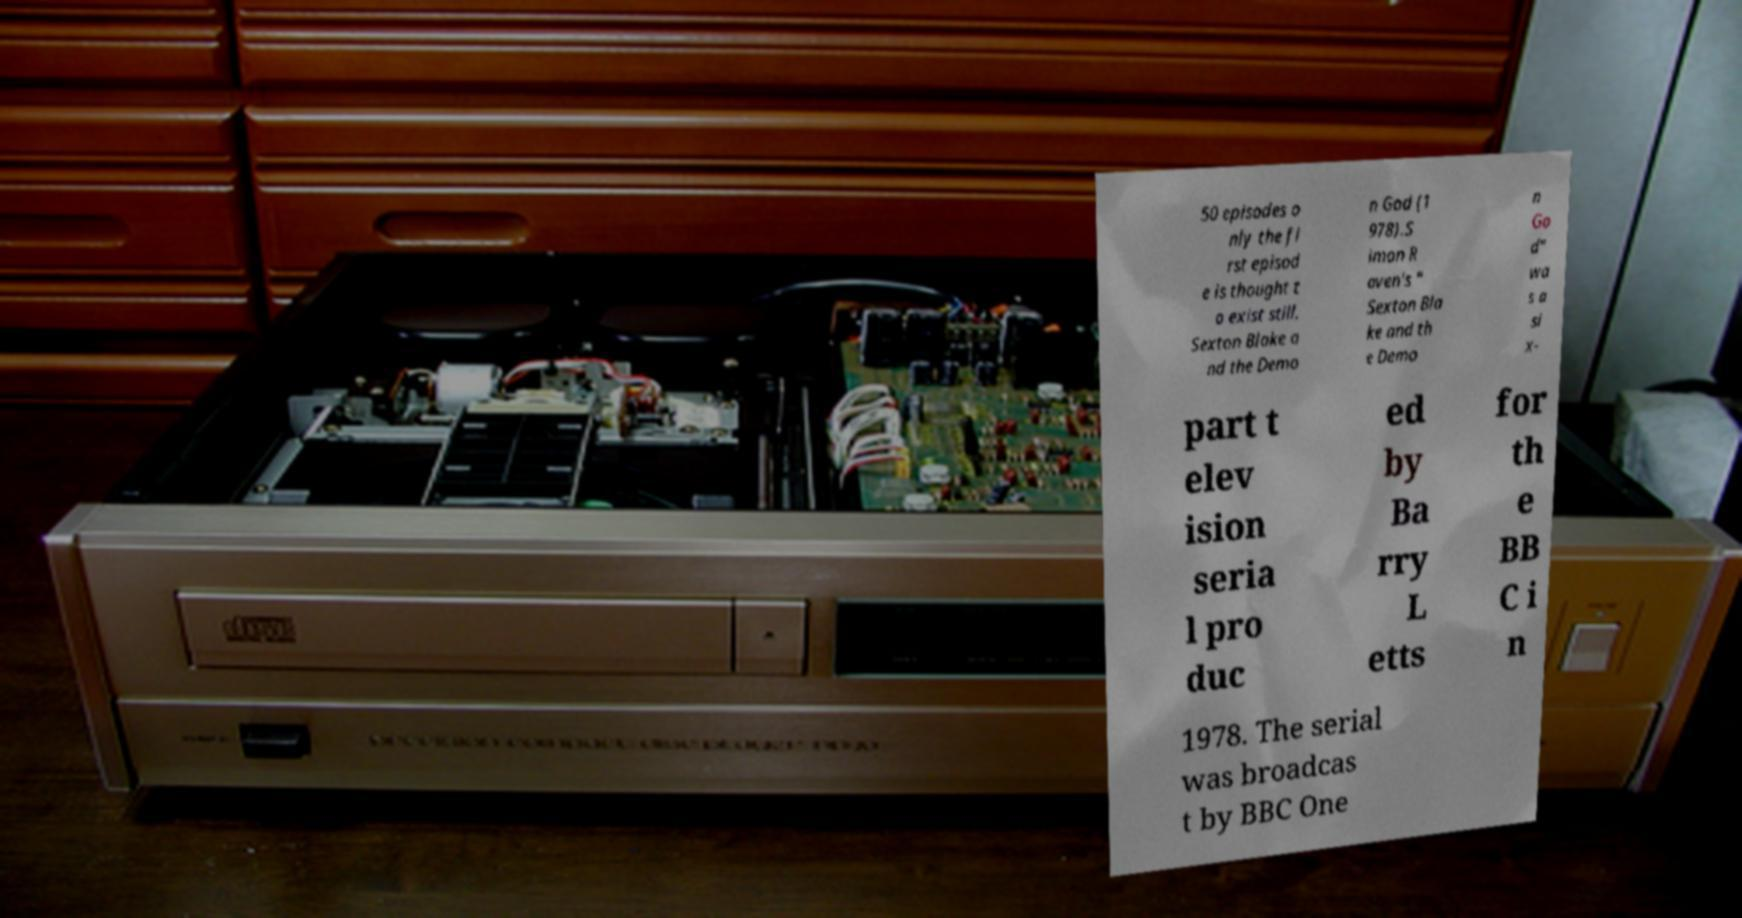Please read and relay the text visible in this image. What does it say? 50 episodes o nly the fi rst episod e is thought t o exist still. Sexton Blake a nd the Demo n God (1 978).S imon R aven's " Sexton Bla ke and th e Demo n Go d" wa s a si x- part t elev ision seria l pro duc ed by Ba rry L etts for th e BB C i n 1978. The serial was broadcas t by BBC One 